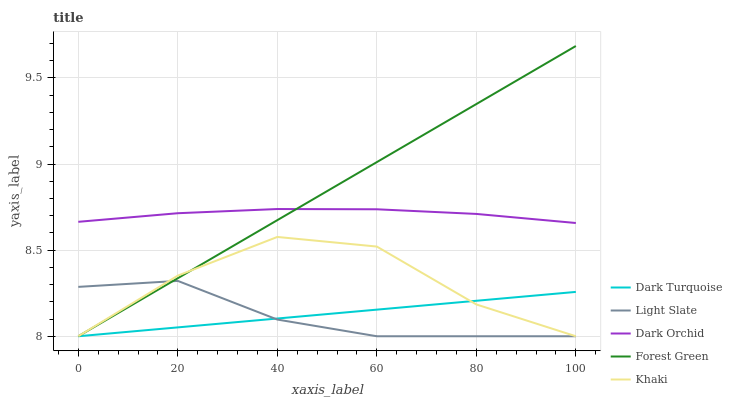Does Light Slate have the minimum area under the curve?
Answer yes or no. Yes. Does Forest Green have the maximum area under the curve?
Answer yes or no. Yes. Does Dark Turquoise have the minimum area under the curve?
Answer yes or no. No. Does Dark Turquoise have the maximum area under the curve?
Answer yes or no. No. Is Dark Turquoise the smoothest?
Answer yes or no. Yes. Is Khaki the roughest?
Answer yes or no. Yes. Is Forest Green the smoothest?
Answer yes or no. No. Is Forest Green the roughest?
Answer yes or no. No. Does Light Slate have the lowest value?
Answer yes or no. Yes. Does Dark Orchid have the lowest value?
Answer yes or no. No. Does Forest Green have the highest value?
Answer yes or no. Yes. Does Dark Turquoise have the highest value?
Answer yes or no. No. Is Khaki less than Dark Orchid?
Answer yes or no. Yes. Is Dark Orchid greater than Light Slate?
Answer yes or no. Yes. Does Light Slate intersect Dark Turquoise?
Answer yes or no. Yes. Is Light Slate less than Dark Turquoise?
Answer yes or no. No. Is Light Slate greater than Dark Turquoise?
Answer yes or no. No. Does Khaki intersect Dark Orchid?
Answer yes or no. No. 